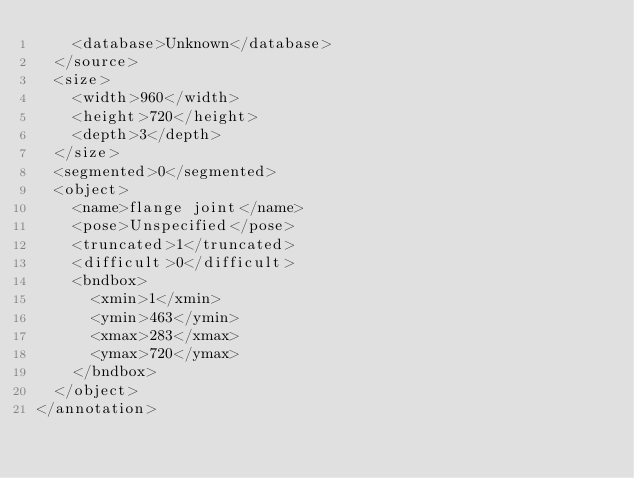Convert code to text. <code><loc_0><loc_0><loc_500><loc_500><_XML_>		<database>Unknown</database>
	</source>
	<size>
		<width>960</width>
		<height>720</height>
		<depth>3</depth>
	</size>
	<segmented>0</segmented>
	<object>
		<name>flange joint</name>
		<pose>Unspecified</pose>
		<truncated>1</truncated>
		<difficult>0</difficult>
		<bndbox>
			<xmin>1</xmin>
			<ymin>463</ymin>
			<xmax>283</xmax>
			<ymax>720</ymax>
		</bndbox>
	</object>
</annotation>
</code> 